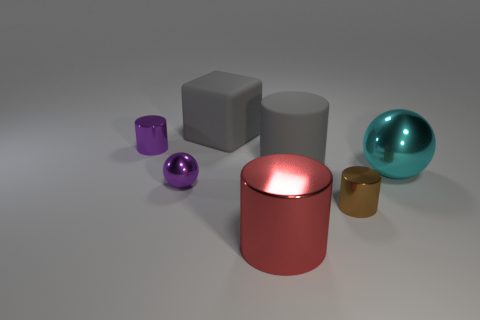Subtract all purple cylinders. How many cylinders are left? 3 Subtract all shiny cylinders. How many cylinders are left? 1 Subtract all blocks. How many objects are left? 6 Add 2 cylinders. How many objects exist? 9 Subtract 2 spheres. How many spheres are left? 0 Add 3 gray matte cylinders. How many gray matte cylinders exist? 4 Subtract 0 green cylinders. How many objects are left? 7 Subtract all red spheres. Subtract all cyan cylinders. How many spheres are left? 2 Subtract all red cylinders. How many purple spheres are left? 1 Subtract all tiny purple shiny balls. Subtract all gray matte things. How many objects are left? 4 